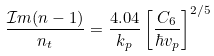Convert formula to latex. <formula><loc_0><loc_0><loc_500><loc_500>\frac { \mathcal { I } m ( n - 1 ) } { n _ { t } } = \frac { 4 . 0 4 } { k _ { p } } \left [ \frac { C _ { 6 } } { \hbar { v } _ { p } } \right ] ^ { 2 / 5 }</formula> 